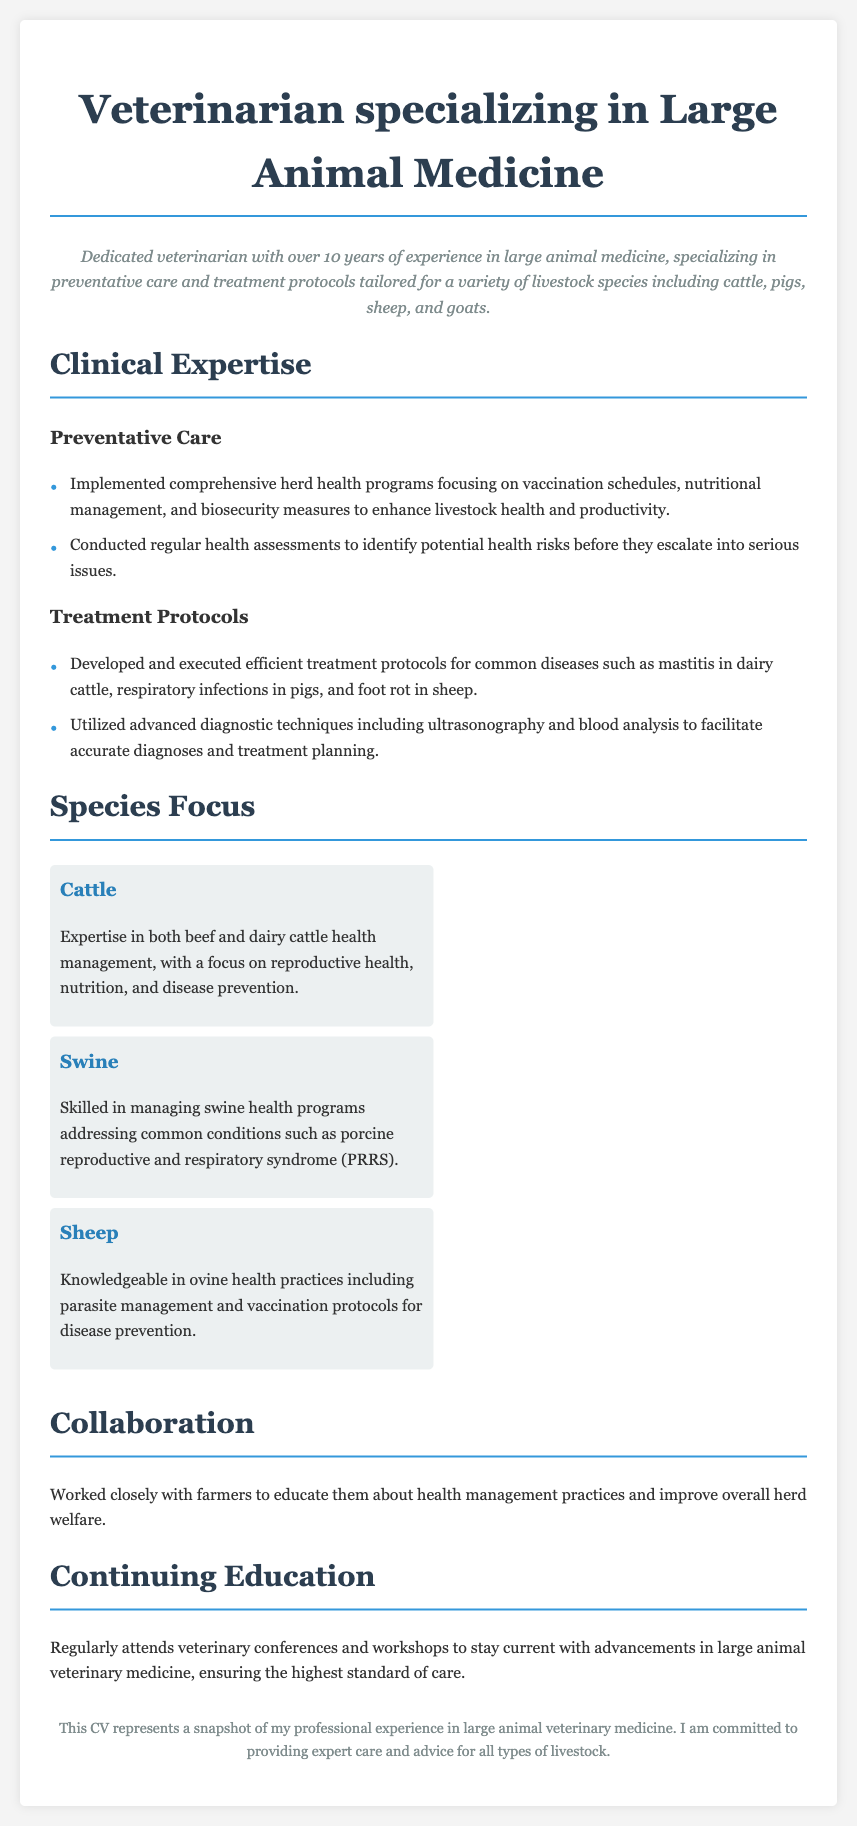What is the veterinarian's specialty? The document specifies the veterinarian's specialty as large animal medicine.
Answer: large animal medicine How many years of experience does the veterinarian have? The document states that the veterinarian has over 10 years of experience.
Answer: over 10 years What type of livestock species is mentioned in the professional summary? The document lists cattle, pigs, sheep, and goats as the livestock species the veterinarian specializes in.
Answer: cattle, pigs, sheep, and goats What disease is specifically mentioned related to dairy cattle? The document highlights mastitis as a common disease treated in dairy cattle.
Answer: mastitis Which health program is emphasized for swine in the clinical expertise section? The document refers to porcine reproductive and respiratory syndrome (PRRS) as a condition addressed in swine health programs.
Answer: porcine reproductive and respiratory syndrome (PRRS) What is one of the advanced diagnostic techniques used by the veterinarian? The document mentions ultrasonography as an advanced diagnostic technique utilized.
Answer: ultrasonography In which section is the collaboration with farmers discussed? The document discusses collaboration in the section titled "Collaboration."
Answer: Collaboration What is the focus of the continuing education mentioned in the CV? The document details that the continuing education involves staying current with advancements in large animal veterinary medicine.
Answer: advancements in large animal veterinary medicine 